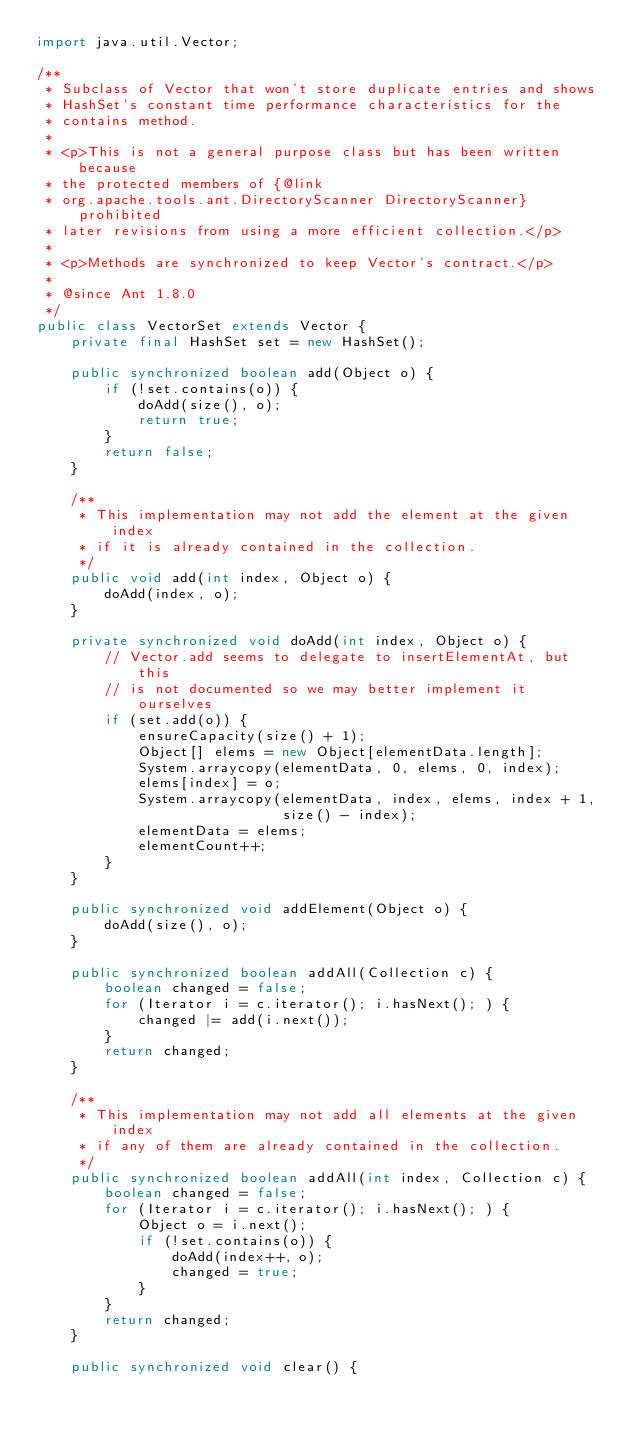<code> <loc_0><loc_0><loc_500><loc_500><_Java_>import java.util.Vector;

/**
 * Subclass of Vector that won't store duplicate entries and shows
 * HashSet's constant time performance characteristics for the
 * contains method.
 *
 * <p>This is not a general purpose class but has been written because
 * the protected members of {@link
 * org.apache.tools.ant.DirectoryScanner DirectoryScanner} prohibited
 * later revisions from using a more efficient collection.</p>
 *
 * <p>Methods are synchronized to keep Vector's contract.</p>
 *
 * @since Ant 1.8.0
 */
public class VectorSet extends Vector {
    private final HashSet set = new HashSet();

    public synchronized boolean add(Object o) {
        if (!set.contains(o)) {
            doAdd(size(), o);
            return true;
        }
        return false;
    }

    /**
     * This implementation may not add the element at the given index
     * if it is already contained in the collection.
     */
    public void add(int index, Object o) {
        doAdd(index, o);
    }

    private synchronized void doAdd(int index, Object o) {
        // Vector.add seems to delegate to insertElementAt, but this
        // is not documented so we may better implement it ourselves
        if (set.add(o)) {
            ensureCapacity(size() + 1);
            Object[] elems = new Object[elementData.length];
            System.arraycopy(elementData, 0, elems, 0, index);
            elems[index] = o;
            System.arraycopy(elementData, index, elems, index + 1,
                             size() - index);
            elementData = elems;
            elementCount++;
        }
    }

    public synchronized void addElement(Object o) {
        doAdd(size(), o);
    }

    public synchronized boolean addAll(Collection c) {
        boolean changed = false;
        for (Iterator i = c.iterator(); i.hasNext(); ) {
            changed |= add(i.next());
        }
        return changed;
    }

    /**
     * This implementation may not add all elements at the given index
     * if any of them are already contained in the collection.
     */
    public synchronized boolean addAll(int index, Collection c) {
        boolean changed = false;
        for (Iterator i = c.iterator(); i.hasNext(); ) {
            Object o = i.next();
            if (!set.contains(o)) {
                doAdd(index++, o);
                changed = true;
            }
        }
        return changed;
    }

    public synchronized void clear() {</code> 